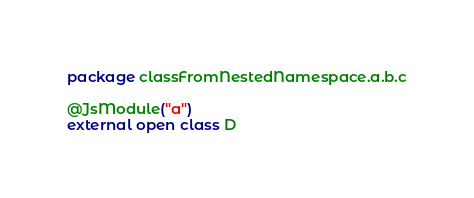<code> <loc_0><loc_0><loc_500><loc_500><_Kotlin_>package classFromNestedNamespace.a.b.c

@JsModule("a")
external open class D
</code> 